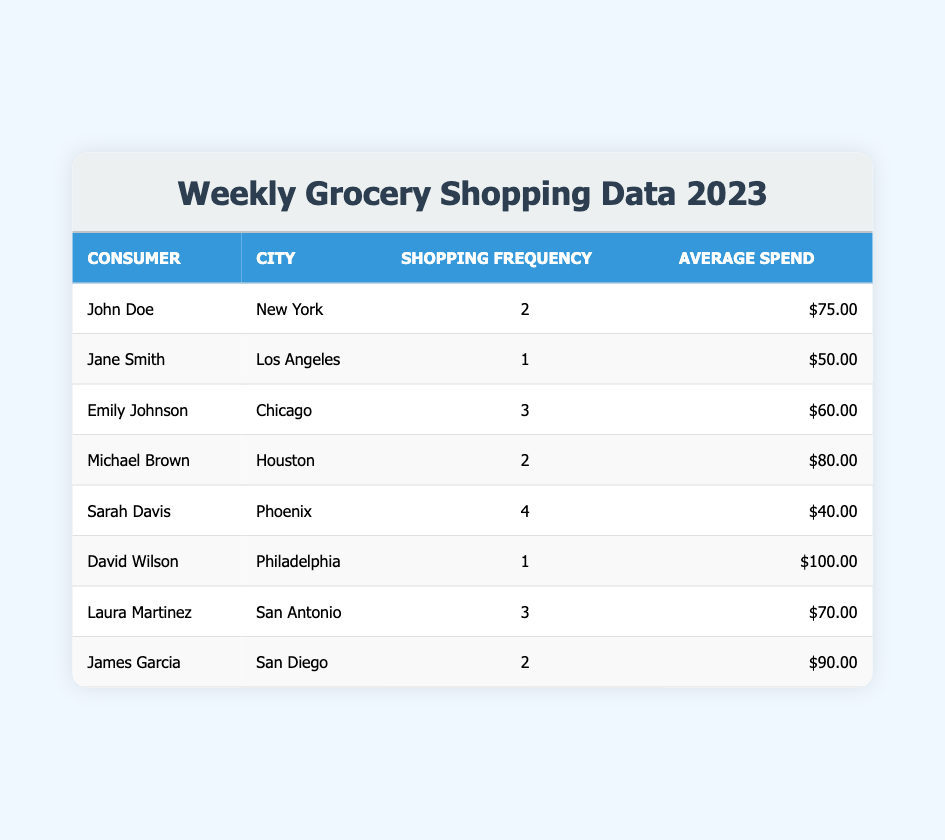What is the average spend per visit for all consumers in the table? To find the average spend, we add the average spends of all consumers, which are 75.00, 50.00, 60.00, 80.00, 40.00, 100.00, 70.00, and 90.00. The total is 75 + 50 + 60 + 80 + 40 + 100 + 70 + 90 = 565. There are 8 consumers, so we divide the total by 8: 565 / 8 = 70.625.
Answer: 70.63 What is the shopping frequency of Sarah Davis? In the table, Sarah Davis is listed under Consumer with a Shopping Frequency of 4.
Answer: 4 Is there any consumer in the table who spends an average of more than 80 dollars per visit? By scanning the Average Spend column, we see that David Wilson spends 100.00, James Garcia spends 90.00, and Michael Brown spends 80.00. Therefore, yes, David Wilson and James Garcia spend more than 80 dollars.
Answer: Yes Who has the highest shopping frequency in the table? We compare the Shopping Frequency values: John Doe (2), Jane Smith (1), Emily Johnson (3), Michael Brown (2), Sarah Davis (4), David Wilson (1), Laura Martinez (3), James Garcia (2). Sarah Davis has the highest frequency at 4 visits.
Answer: Sarah Davis What is the total average spend for consumers who shop more than two times a week? The consumers with frequencies greater than two are Emily Johnson (60.00), Sarah Davis (40.00), and Laura Martinez (70.00). Their average spends sum to 60 + 40 + 70 = 170. Since there are 3 consumers in this group, we divide that sum by 3: 170 / 3 = 56.67.
Answer: 56.67 How many consumers shop only once a week according to the table? By looking at the Shopping Frequency column, we identify Jane Smith and David Wilson, both of whom shop only once a week. Therefore, there are 2 consumers who shop once a week.
Answer: 2 What is the average spend of shoppers from New York and Chicago combined? The shoppers are John Doe from New York (average spend 75.00) and Emily Johnson from Chicago (average spend 60.00). We calculate their combined average spend: 75 + 60 = 135. There are 2 of them, so we divide 135 by 2 to get an average of 67.50.
Answer: 67.50 Are there consumers in the table who spend less than 50 dollars per visit? Scanning the Average Spend column, the lowest value is 40.00 (Sarah Davis), which is less than 50. Therefore, the answer is yes.
Answer: Yes 